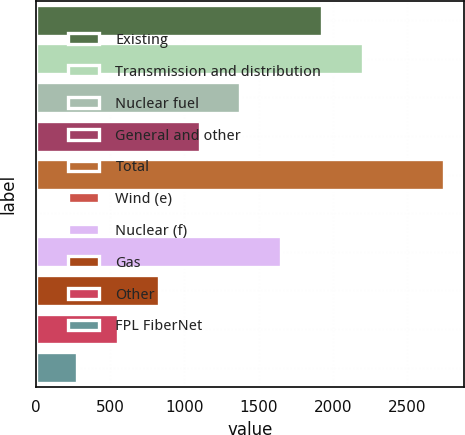Convert chart. <chart><loc_0><loc_0><loc_500><loc_500><bar_chart><fcel>Existing<fcel>Transmission and distribution<fcel>Nuclear fuel<fcel>General and other<fcel>Total<fcel>Wind (e)<fcel>Nuclear (f)<fcel>Gas<fcel>Other<fcel>FPL FiberNet<nl><fcel>1926.5<fcel>2201<fcel>1377.5<fcel>1103<fcel>2750<fcel>5<fcel>1652<fcel>828.5<fcel>554<fcel>279.5<nl></chart> 